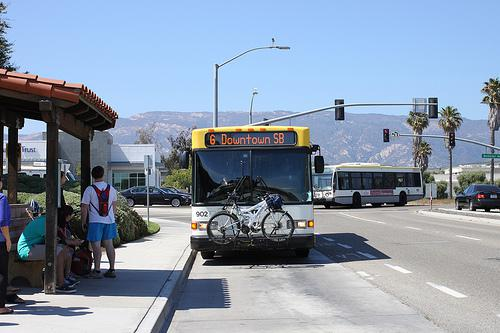Question: what is on the street?
Choices:
A. Trains.
B. Motorcycles.
C. Trucks.
D. Buses.
Answer with the letter. Answer: D Question: what will it pick up?
Choices:
A. Babies.
B. Cows.
C. People.
D. Millionaires.
Answer with the letter. Answer: C Question: what is on the front?
Choices:
A. Bike.
B. Motorcycle.
C. Scooter.
D. Skateboard.
Answer with the letter. Answer: A Question: where are the people?
Choices:
A. Church.
B. Grocery store.
C. Bus stop.
D. Concert.
Answer with the letter. Answer: C 